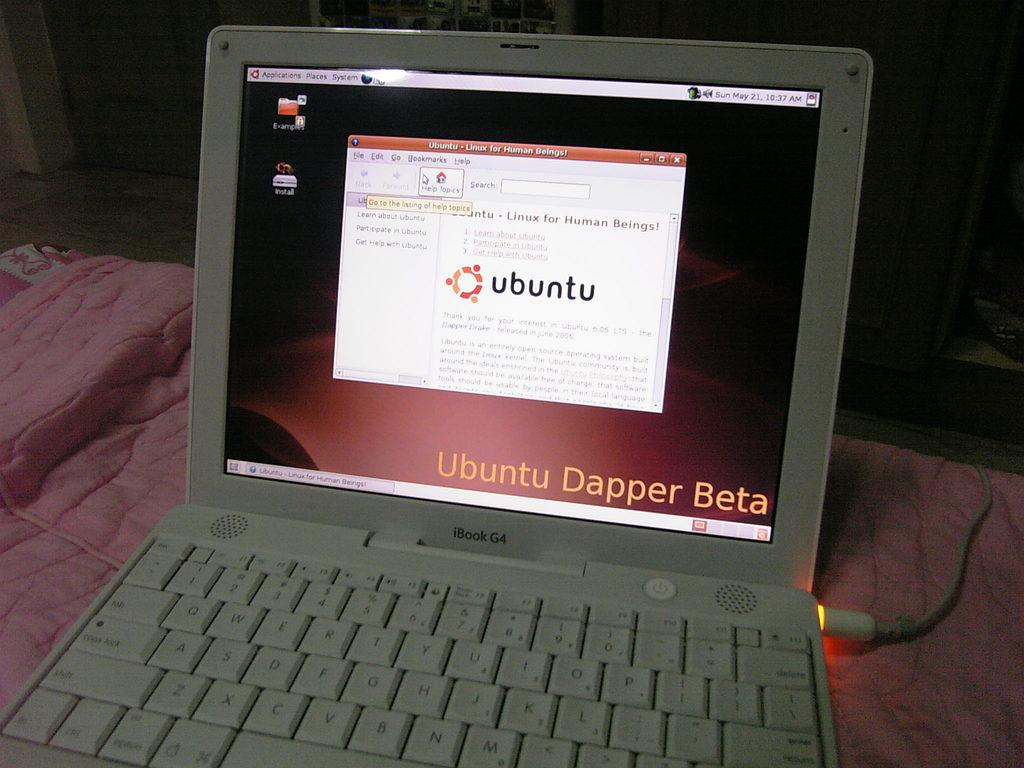Provide a one-sentence caption for the provided image. A Mac iBook computer is running an installation of Ubuntu. 